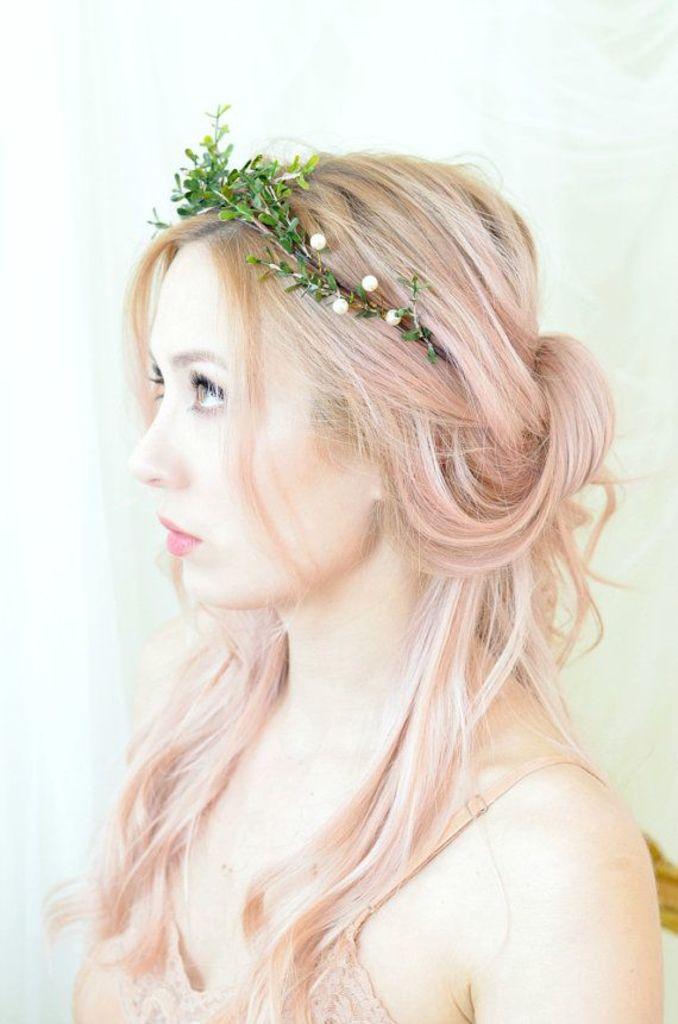Can you describe this image briefly? In this image there is a woman wearing a ring made up of leaves which is also known as hair band. 